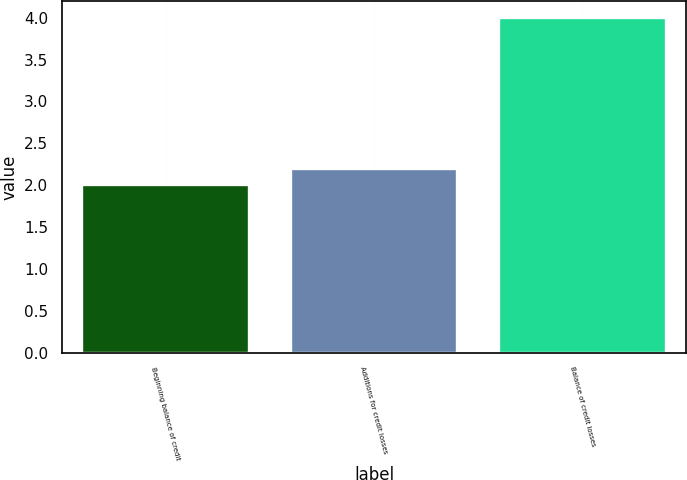Convert chart to OTSL. <chart><loc_0><loc_0><loc_500><loc_500><bar_chart><fcel>Beginning balance of credit<fcel>Additions for credit losses<fcel>Balance of credit losses<nl><fcel>2<fcel>2.2<fcel>4<nl></chart> 